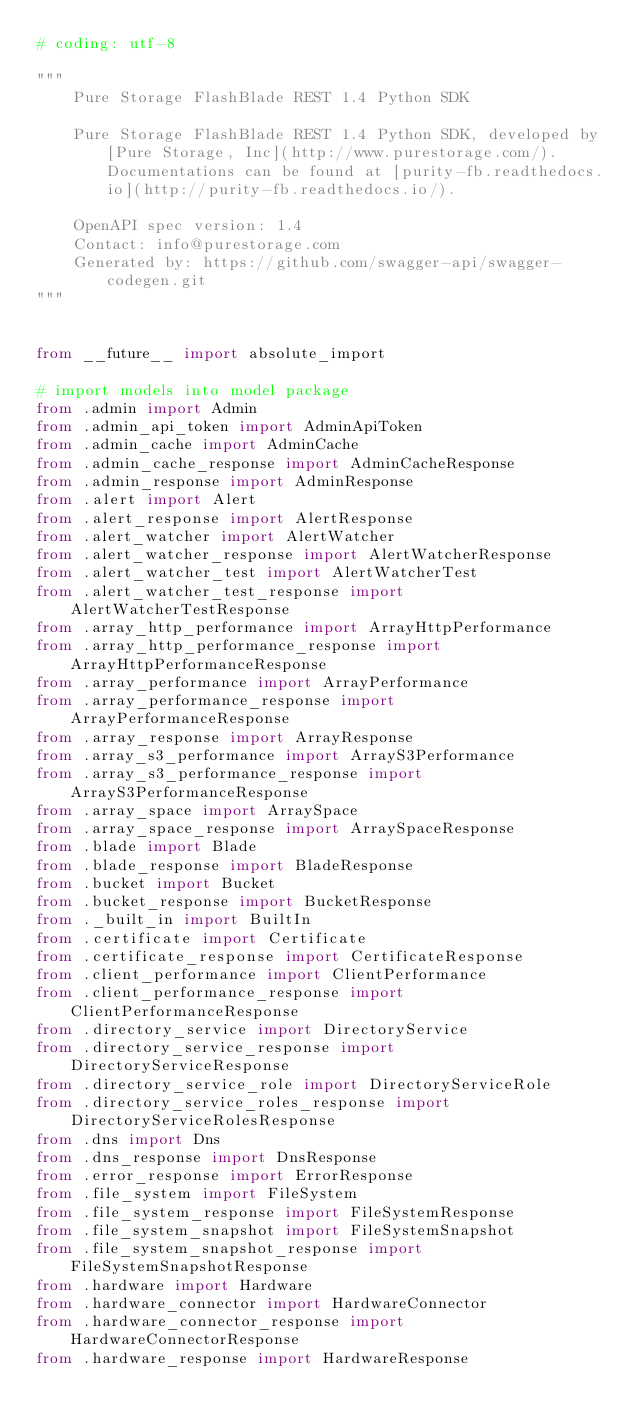Convert code to text. <code><loc_0><loc_0><loc_500><loc_500><_Python_># coding: utf-8

"""
    Pure Storage FlashBlade REST 1.4 Python SDK

    Pure Storage FlashBlade REST 1.4 Python SDK, developed by [Pure Storage, Inc](http://www.purestorage.com/). Documentations can be found at [purity-fb.readthedocs.io](http://purity-fb.readthedocs.io/).

    OpenAPI spec version: 1.4
    Contact: info@purestorage.com
    Generated by: https://github.com/swagger-api/swagger-codegen.git
"""


from __future__ import absolute_import

# import models into model package
from .admin import Admin
from .admin_api_token import AdminApiToken
from .admin_cache import AdminCache
from .admin_cache_response import AdminCacheResponse
from .admin_response import AdminResponse
from .alert import Alert
from .alert_response import AlertResponse
from .alert_watcher import AlertWatcher
from .alert_watcher_response import AlertWatcherResponse
from .alert_watcher_test import AlertWatcherTest
from .alert_watcher_test_response import AlertWatcherTestResponse
from .array_http_performance import ArrayHttpPerformance
from .array_http_performance_response import ArrayHttpPerformanceResponse
from .array_performance import ArrayPerformance
from .array_performance_response import ArrayPerformanceResponse
from .array_response import ArrayResponse
from .array_s3_performance import ArrayS3Performance
from .array_s3_performance_response import ArrayS3PerformanceResponse
from .array_space import ArraySpace
from .array_space_response import ArraySpaceResponse
from .blade import Blade
from .blade_response import BladeResponse
from .bucket import Bucket
from .bucket_response import BucketResponse
from ._built_in import BuiltIn
from .certificate import Certificate
from .certificate_response import CertificateResponse
from .client_performance import ClientPerformance
from .client_performance_response import ClientPerformanceResponse
from .directory_service import DirectoryService
from .directory_service_response import DirectoryServiceResponse
from .directory_service_role import DirectoryServiceRole
from .directory_service_roles_response import DirectoryServiceRolesResponse
from .dns import Dns
from .dns_response import DnsResponse
from .error_response import ErrorResponse
from .file_system import FileSystem
from .file_system_response import FileSystemResponse
from .file_system_snapshot import FileSystemSnapshot
from .file_system_snapshot_response import FileSystemSnapshotResponse
from .hardware import Hardware
from .hardware_connector import HardwareConnector
from .hardware_connector_response import HardwareConnectorResponse
from .hardware_response import HardwareResponse</code> 